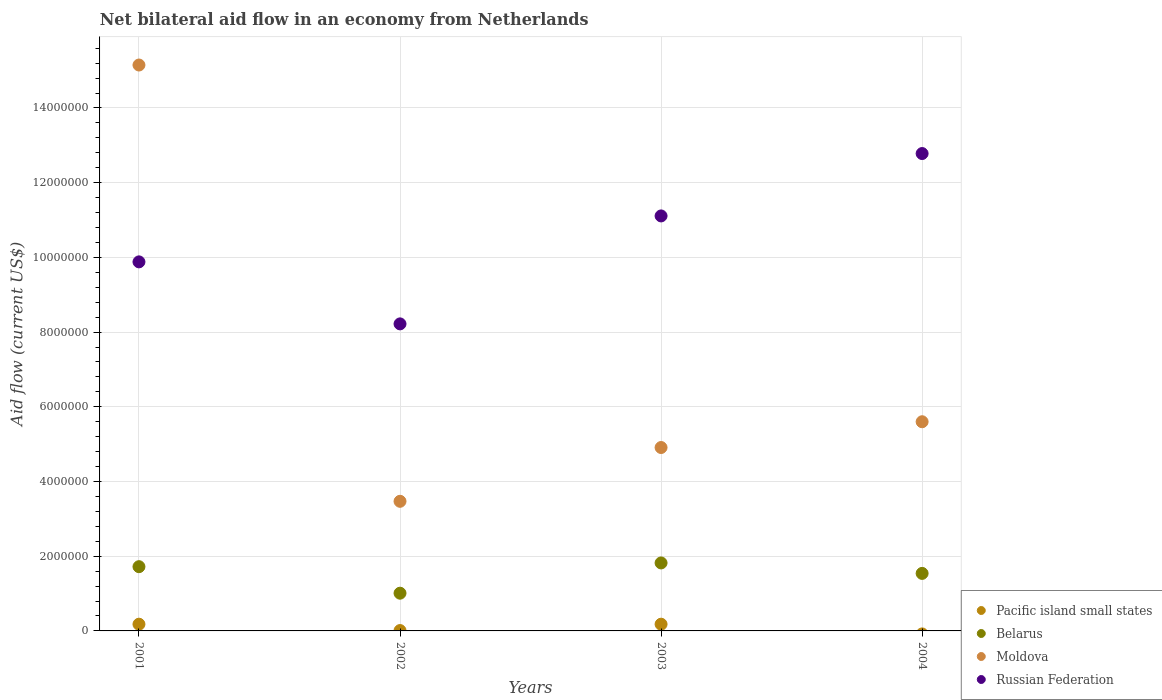What is the net bilateral aid flow in Belarus in 2001?
Ensure brevity in your answer.  1.72e+06. Across all years, what is the maximum net bilateral aid flow in Moldova?
Offer a terse response. 1.52e+07. Across all years, what is the minimum net bilateral aid flow in Russian Federation?
Offer a terse response. 8.22e+06. In which year was the net bilateral aid flow in Belarus maximum?
Provide a succinct answer. 2003. What is the total net bilateral aid flow in Belarus in the graph?
Keep it short and to the point. 6.09e+06. What is the difference between the net bilateral aid flow in Moldova in 2004 and the net bilateral aid flow in Russian Federation in 2001?
Offer a very short reply. -4.28e+06. What is the average net bilateral aid flow in Russian Federation per year?
Your response must be concise. 1.05e+07. In the year 2002, what is the difference between the net bilateral aid flow in Pacific island small states and net bilateral aid flow in Moldova?
Offer a very short reply. -3.46e+06. In how many years, is the net bilateral aid flow in Pacific island small states greater than 11200000 US$?
Offer a terse response. 0. What is the ratio of the net bilateral aid flow in Russian Federation in 2001 to that in 2004?
Give a very brief answer. 0.77. Is the net bilateral aid flow in Belarus in 2001 less than that in 2003?
Provide a succinct answer. Yes. Is the difference between the net bilateral aid flow in Pacific island small states in 2001 and 2002 greater than the difference between the net bilateral aid flow in Moldova in 2001 and 2002?
Keep it short and to the point. No. What is the difference between the highest and the second highest net bilateral aid flow in Moldova?
Ensure brevity in your answer.  9.55e+06. What is the difference between the highest and the lowest net bilateral aid flow in Belarus?
Keep it short and to the point. 8.10e+05. Is the sum of the net bilateral aid flow in Moldova in 2003 and 2004 greater than the maximum net bilateral aid flow in Russian Federation across all years?
Provide a short and direct response. No. Is it the case that in every year, the sum of the net bilateral aid flow in Belarus and net bilateral aid flow in Moldova  is greater than the net bilateral aid flow in Pacific island small states?
Offer a very short reply. Yes. How many dotlines are there?
Your response must be concise. 4. How many years are there in the graph?
Your answer should be compact. 4. How many legend labels are there?
Your response must be concise. 4. How are the legend labels stacked?
Your answer should be compact. Vertical. What is the title of the graph?
Offer a terse response. Net bilateral aid flow in an economy from Netherlands. What is the label or title of the X-axis?
Offer a very short reply. Years. What is the Aid flow (current US$) of Pacific island small states in 2001?
Provide a short and direct response. 1.80e+05. What is the Aid flow (current US$) of Belarus in 2001?
Your answer should be compact. 1.72e+06. What is the Aid flow (current US$) of Moldova in 2001?
Provide a short and direct response. 1.52e+07. What is the Aid flow (current US$) of Russian Federation in 2001?
Keep it short and to the point. 9.88e+06. What is the Aid flow (current US$) in Belarus in 2002?
Keep it short and to the point. 1.01e+06. What is the Aid flow (current US$) of Moldova in 2002?
Offer a terse response. 3.47e+06. What is the Aid flow (current US$) of Russian Federation in 2002?
Provide a short and direct response. 8.22e+06. What is the Aid flow (current US$) in Pacific island small states in 2003?
Keep it short and to the point. 1.80e+05. What is the Aid flow (current US$) in Belarus in 2003?
Offer a very short reply. 1.82e+06. What is the Aid flow (current US$) in Moldova in 2003?
Provide a short and direct response. 4.91e+06. What is the Aid flow (current US$) in Russian Federation in 2003?
Provide a short and direct response. 1.11e+07. What is the Aid flow (current US$) in Pacific island small states in 2004?
Provide a succinct answer. 0. What is the Aid flow (current US$) of Belarus in 2004?
Your answer should be compact. 1.54e+06. What is the Aid flow (current US$) in Moldova in 2004?
Your answer should be very brief. 5.60e+06. What is the Aid flow (current US$) in Russian Federation in 2004?
Your answer should be compact. 1.28e+07. Across all years, what is the maximum Aid flow (current US$) in Belarus?
Your response must be concise. 1.82e+06. Across all years, what is the maximum Aid flow (current US$) in Moldova?
Your response must be concise. 1.52e+07. Across all years, what is the maximum Aid flow (current US$) of Russian Federation?
Make the answer very short. 1.28e+07. Across all years, what is the minimum Aid flow (current US$) in Belarus?
Provide a succinct answer. 1.01e+06. Across all years, what is the minimum Aid flow (current US$) in Moldova?
Ensure brevity in your answer.  3.47e+06. Across all years, what is the minimum Aid flow (current US$) of Russian Federation?
Keep it short and to the point. 8.22e+06. What is the total Aid flow (current US$) of Pacific island small states in the graph?
Give a very brief answer. 3.70e+05. What is the total Aid flow (current US$) in Belarus in the graph?
Provide a succinct answer. 6.09e+06. What is the total Aid flow (current US$) in Moldova in the graph?
Offer a very short reply. 2.91e+07. What is the total Aid flow (current US$) of Russian Federation in the graph?
Your answer should be compact. 4.20e+07. What is the difference between the Aid flow (current US$) of Pacific island small states in 2001 and that in 2002?
Provide a succinct answer. 1.70e+05. What is the difference between the Aid flow (current US$) of Belarus in 2001 and that in 2002?
Your answer should be very brief. 7.10e+05. What is the difference between the Aid flow (current US$) in Moldova in 2001 and that in 2002?
Offer a terse response. 1.17e+07. What is the difference between the Aid flow (current US$) of Russian Federation in 2001 and that in 2002?
Your answer should be very brief. 1.66e+06. What is the difference between the Aid flow (current US$) in Belarus in 2001 and that in 2003?
Your answer should be compact. -1.00e+05. What is the difference between the Aid flow (current US$) of Moldova in 2001 and that in 2003?
Make the answer very short. 1.02e+07. What is the difference between the Aid flow (current US$) in Russian Federation in 2001 and that in 2003?
Your answer should be very brief. -1.23e+06. What is the difference between the Aid flow (current US$) in Moldova in 2001 and that in 2004?
Your answer should be very brief. 9.55e+06. What is the difference between the Aid flow (current US$) in Russian Federation in 2001 and that in 2004?
Give a very brief answer. -2.90e+06. What is the difference between the Aid flow (current US$) in Belarus in 2002 and that in 2003?
Offer a very short reply. -8.10e+05. What is the difference between the Aid flow (current US$) of Moldova in 2002 and that in 2003?
Your response must be concise. -1.44e+06. What is the difference between the Aid flow (current US$) of Russian Federation in 2002 and that in 2003?
Your response must be concise. -2.89e+06. What is the difference between the Aid flow (current US$) in Belarus in 2002 and that in 2004?
Provide a short and direct response. -5.30e+05. What is the difference between the Aid flow (current US$) in Moldova in 2002 and that in 2004?
Keep it short and to the point. -2.13e+06. What is the difference between the Aid flow (current US$) in Russian Federation in 2002 and that in 2004?
Ensure brevity in your answer.  -4.56e+06. What is the difference between the Aid flow (current US$) of Moldova in 2003 and that in 2004?
Offer a terse response. -6.90e+05. What is the difference between the Aid flow (current US$) in Russian Federation in 2003 and that in 2004?
Provide a short and direct response. -1.67e+06. What is the difference between the Aid flow (current US$) of Pacific island small states in 2001 and the Aid flow (current US$) of Belarus in 2002?
Offer a very short reply. -8.30e+05. What is the difference between the Aid flow (current US$) in Pacific island small states in 2001 and the Aid flow (current US$) in Moldova in 2002?
Offer a terse response. -3.29e+06. What is the difference between the Aid flow (current US$) of Pacific island small states in 2001 and the Aid flow (current US$) of Russian Federation in 2002?
Offer a terse response. -8.04e+06. What is the difference between the Aid flow (current US$) of Belarus in 2001 and the Aid flow (current US$) of Moldova in 2002?
Give a very brief answer. -1.75e+06. What is the difference between the Aid flow (current US$) in Belarus in 2001 and the Aid flow (current US$) in Russian Federation in 2002?
Your response must be concise. -6.50e+06. What is the difference between the Aid flow (current US$) of Moldova in 2001 and the Aid flow (current US$) of Russian Federation in 2002?
Offer a terse response. 6.93e+06. What is the difference between the Aid flow (current US$) of Pacific island small states in 2001 and the Aid flow (current US$) of Belarus in 2003?
Make the answer very short. -1.64e+06. What is the difference between the Aid flow (current US$) of Pacific island small states in 2001 and the Aid flow (current US$) of Moldova in 2003?
Make the answer very short. -4.73e+06. What is the difference between the Aid flow (current US$) of Pacific island small states in 2001 and the Aid flow (current US$) of Russian Federation in 2003?
Your answer should be compact. -1.09e+07. What is the difference between the Aid flow (current US$) of Belarus in 2001 and the Aid flow (current US$) of Moldova in 2003?
Give a very brief answer. -3.19e+06. What is the difference between the Aid flow (current US$) in Belarus in 2001 and the Aid flow (current US$) in Russian Federation in 2003?
Provide a short and direct response. -9.39e+06. What is the difference between the Aid flow (current US$) in Moldova in 2001 and the Aid flow (current US$) in Russian Federation in 2003?
Provide a succinct answer. 4.04e+06. What is the difference between the Aid flow (current US$) of Pacific island small states in 2001 and the Aid flow (current US$) of Belarus in 2004?
Your answer should be compact. -1.36e+06. What is the difference between the Aid flow (current US$) in Pacific island small states in 2001 and the Aid flow (current US$) in Moldova in 2004?
Your answer should be compact. -5.42e+06. What is the difference between the Aid flow (current US$) in Pacific island small states in 2001 and the Aid flow (current US$) in Russian Federation in 2004?
Your answer should be compact. -1.26e+07. What is the difference between the Aid flow (current US$) of Belarus in 2001 and the Aid flow (current US$) of Moldova in 2004?
Your answer should be very brief. -3.88e+06. What is the difference between the Aid flow (current US$) in Belarus in 2001 and the Aid flow (current US$) in Russian Federation in 2004?
Your response must be concise. -1.11e+07. What is the difference between the Aid flow (current US$) of Moldova in 2001 and the Aid flow (current US$) of Russian Federation in 2004?
Give a very brief answer. 2.37e+06. What is the difference between the Aid flow (current US$) of Pacific island small states in 2002 and the Aid flow (current US$) of Belarus in 2003?
Provide a succinct answer. -1.81e+06. What is the difference between the Aid flow (current US$) in Pacific island small states in 2002 and the Aid flow (current US$) in Moldova in 2003?
Provide a succinct answer. -4.90e+06. What is the difference between the Aid flow (current US$) in Pacific island small states in 2002 and the Aid flow (current US$) in Russian Federation in 2003?
Make the answer very short. -1.11e+07. What is the difference between the Aid flow (current US$) of Belarus in 2002 and the Aid flow (current US$) of Moldova in 2003?
Your answer should be compact. -3.90e+06. What is the difference between the Aid flow (current US$) in Belarus in 2002 and the Aid flow (current US$) in Russian Federation in 2003?
Offer a terse response. -1.01e+07. What is the difference between the Aid flow (current US$) in Moldova in 2002 and the Aid flow (current US$) in Russian Federation in 2003?
Provide a short and direct response. -7.64e+06. What is the difference between the Aid flow (current US$) in Pacific island small states in 2002 and the Aid flow (current US$) in Belarus in 2004?
Your answer should be very brief. -1.53e+06. What is the difference between the Aid flow (current US$) in Pacific island small states in 2002 and the Aid flow (current US$) in Moldova in 2004?
Your response must be concise. -5.59e+06. What is the difference between the Aid flow (current US$) in Pacific island small states in 2002 and the Aid flow (current US$) in Russian Federation in 2004?
Provide a short and direct response. -1.28e+07. What is the difference between the Aid flow (current US$) of Belarus in 2002 and the Aid flow (current US$) of Moldova in 2004?
Your response must be concise. -4.59e+06. What is the difference between the Aid flow (current US$) of Belarus in 2002 and the Aid flow (current US$) of Russian Federation in 2004?
Your answer should be compact. -1.18e+07. What is the difference between the Aid flow (current US$) of Moldova in 2002 and the Aid flow (current US$) of Russian Federation in 2004?
Keep it short and to the point. -9.31e+06. What is the difference between the Aid flow (current US$) of Pacific island small states in 2003 and the Aid flow (current US$) of Belarus in 2004?
Keep it short and to the point. -1.36e+06. What is the difference between the Aid flow (current US$) in Pacific island small states in 2003 and the Aid flow (current US$) in Moldova in 2004?
Keep it short and to the point. -5.42e+06. What is the difference between the Aid flow (current US$) of Pacific island small states in 2003 and the Aid flow (current US$) of Russian Federation in 2004?
Your answer should be very brief. -1.26e+07. What is the difference between the Aid flow (current US$) in Belarus in 2003 and the Aid flow (current US$) in Moldova in 2004?
Keep it short and to the point. -3.78e+06. What is the difference between the Aid flow (current US$) of Belarus in 2003 and the Aid flow (current US$) of Russian Federation in 2004?
Offer a very short reply. -1.10e+07. What is the difference between the Aid flow (current US$) in Moldova in 2003 and the Aid flow (current US$) in Russian Federation in 2004?
Ensure brevity in your answer.  -7.87e+06. What is the average Aid flow (current US$) in Pacific island small states per year?
Offer a terse response. 9.25e+04. What is the average Aid flow (current US$) in Belarus per year?
Keep it short and to the point. 1.52e+06. What is the average Aid flow (current US$) in Moldova per year?
Keep it short and to the point. 7.28e+06. What is the average Aid flow (current US$) of Russian Federation per year?
Offer a terse response. 1.05e+07. In the year 2001, what is the difference between the Aid flow (current US$) in Pacific island small states and Aid flow (current US$) in Belarus?
Offer a very short reply. -1.54e+06. In the year 2001, what is the difference between the Aid flow (current US$) of Pacific island small states and Aid flow (current US$) of Moldova?
Make the answer very short. -1.50e+07. In the year 2001, what is the difference between the Aid flow (current US$) of Pacific island small states and Aid flow (current US$) of Russian Federation?
Your response must be concise. -9.70e+06. In the year 2001, what is the difference between the Aid flow (current US$) of Belarus and Aid flow (current US$) of Moldova?
Keep it short and to the point. -1.34e+07. In the year 2001, what is the difference between the Aid flow (current US$) in Belarus and Aid flow (current US$) in Russian Federation?
Keep it short and to the point. -8.16e+06. In the year 2001, what is the difference between the Aid flow (current US$) of Moldova and Aid flow (current US$) of Russian Federation?
Ensure brevity in your answer.  5.27e+06. In the year 2002, what is the difference between the Aid flow (current US$) in Pacific island small states and Aid flow (current US$) in Moldova?
Provide a short and direct response. -3.46e+06. In the year 2002, what is the difference between the Aid flow (current US$) of Pacific island small states and Aid flow (current US$) of Russian Federation?
Make the answer very short. -8.21e+06. In the year 2002, what is the difference between the Aid flow (current US$) in Belarus and Aid flow (current US$) in Moldova?
Your response must be concise. -2.46e+06. In the year 2002, what is the difference between the Aid flow (current US$) in Belarus and Aid flow (current US$) in Russian Federation?
Keep it short and to the point. -7.21e+06. In the year 2002, what is the difference between the Aid flow (current US$) in Moldova and Aid flow (current US$) in Russian Federation?
Offer a terse response. -4.75e+06. In the year 2003, what is the difference between the Aid flow (current US$) of Pacific island small states and Aid flow (current US$) of Belarus?
Make the answer very short. -1.64e+06. In the year 2003, what is the difference between the Aid flow (current US$) in Pacific island small states and Aid flow (current US$) in Moldova?
Provide a short and direct response. -4.73e+06. In the year 2003, what is the difference between the Aid flow (current US$) in Pacific island small states and Aid flow (current US$) in Russian Federation?
Offer a very short reply. -1.09e+07. In the year 2003, what is the difference between the Aid flow (current US$) in Belarus and Aid flow (current US$) in Moldova?
Provide a short and direct response. -3.09e+06. In the year 2003, what is the difference between the Aid flow (current US$) in Belarus and Aid flow (current US$) in Russian Federation?
Your answer should be very brief. -9.29e+06. In the year 2003, what is the difference between the Aid flow (current US$) in Moldova and Aid flow (current US$) in Russian Federation?
Give a very brief answer. -6.20e+06. In the year 2004, what is the difference between the Aid flow (current US$) in Belarus and Aid flow (current US$) in Moldova?
Provide a succinct answer. -4.06e+06. In the year 2004, what is the difference between the Aid flow (current US$) of Belarus and Aid flow (current US$) of Russian Federation?
Provide a short and direct response. -1.12e+07. In the year 2004, what is the difference between the Aid flow (current US$) of Moldova and Aid flow (current US$) of Russian Federation?
Keep it short and to the point. -7.18e+06. What is the ratio of the Aid flow (current US$) in Belarus in 2001 to that in 2002?
Your answer should be very brief. 1.7. What is the ratio of the Aid flow (current US$) in Moldova in 2001 to that in 2002?
Your answer should be very brief. 4.37. What is the ratio of the Aid flow (current US$) in Russian Federation in 2001 to that in 2002?
Offer a terse response. 1.2. What is the ratio of the Aid flow (current US$) in Pacific island small states in 2001 to that in 2003?
Provide a short and direct response. 1. What is the ratio of the Aid flow (current US$) in Belarus in 2001 to that in 2003?
Offer a very short reply. 0.95. What is the ratio of the Aid flow (current US$) of Moldova in 2001 to that in 2003?
Ensure brevity in your answer.  3.09. What is the ratio of the Aid flow (current US$) of Russian Federation in 2001 to that in 2003?
Your answer should be compact. 0.89. What is the ratio of the Aid flow (current US$) in Belarus in 2001 to that in 2004?
Your answer should be compact. 1.12. What is the ratio of the Aid flow (current US$) of Moldova in 2001 to that in 2004?
Your answer should be compact. 2.71. What is the ratio of the Aid flow (current US$) in Russian Federation in 2001 to that in 2004?
Ensure brevity in your answer.  0.77. What is the ratio of the Aid flow (current US$) of Pacific island small states in 2002 to that in 2003?
Your answer should be very brief. 0.06. What is the ratio of the Aid flow (current US$) in Belarus in 2002 to that in 2003?
Offer a very short reply. 0.55. What is the ratio of the Aid flow (current US$) of Moldova in 2002 to that in 2003?
Offer a very short reply. 0.71. What is the ratio of the Aid flow (current US$) in Russian Federation in 2002 to that in 2003?
Your response must be concise. 0.74. What is the ratio of the Aid flow (current US$) in Belarus in 2002 to that in 2004?
Your answer should be very brief. 0.66. What is the ratio of the Aid flow (current US$) of Moldova in 2002 to that in 2004?
Ensure brevity in your answer.  0.62. What is the ratio of the Aid flow (current US$) in Russian Federation in 2002 to that in 2004?
Ensure brevity in your answer.  0.64. What is the ratio of the Aid flow (current US$) of Belarus in 2003 to that in 2004?
Your response must be concise. 1.18. What is the ratio of the Aid flow (current US$) of Moldova in 2003 to that in 2004?
Your answer should be very brief. 0.88. What is the ratio of the Aid flow (current US$) of Russian Federation in 2003 to that in 2004?
Give a very brief answer. 0.87. What is the difference between the highest and the second highest Aid flow (current US$) in Pacific island small states?
Provide a succinct answer. 0. What is the difference between the highest and the second highest Aid flow (current US$) of Moldova?
Your answer should be compact. 9.55e+06. What is the difference between the highest and the second highest Aid flow (current US$) of Russian Federation?
Make the answer very short. 1.67e+06. What is the difference between the highest and the lowest Aid flow (current US$) of Belarus?
Your answer should be very brief. 8.10e+05. What is the difference between the highest and the lowest Aid flow (current US$) in Moldova?
Give a very brief answer. 1.17e+07. What is the difference between the highest and the lowest Aid flow (current US$) of Russian Federation?
Your answer should be very brief. 4.56e+06. 